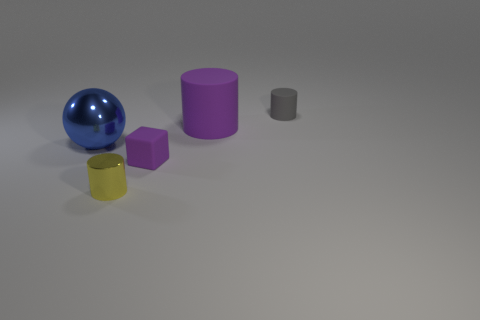Subtract all cylinders. How many objects are left? 2 Subtract all large cylinders. How many cylinders are left? 2 Subtract 0 red balls. How many objects are left? 5 Subtract 1 cubes. How many cubes are left? 0 Subtract all cyan blocks. Subtract all yellow cylinders. How many blocks are left? 1 Subtract all brown blocks. How many red cylinders are left? 0 Subtract all small purple things. Subtract all metallic spheres. How many objects are left? 3 Add 2 tiny shiny objects. How many tiny shiny objects are left? 3 Add 3 purple matte blocks. How many purple matte blocks exist? 4 Add 4 big cylinders. How many objects exist? 9 